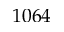Convert formula to latex. <formula><loc_0><loc_0><loc_500><loc_500>1 0 6 4</formula> 